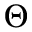<formula> <loc_0><loc_0><loc_500><loc_500>\Theta</formula> 